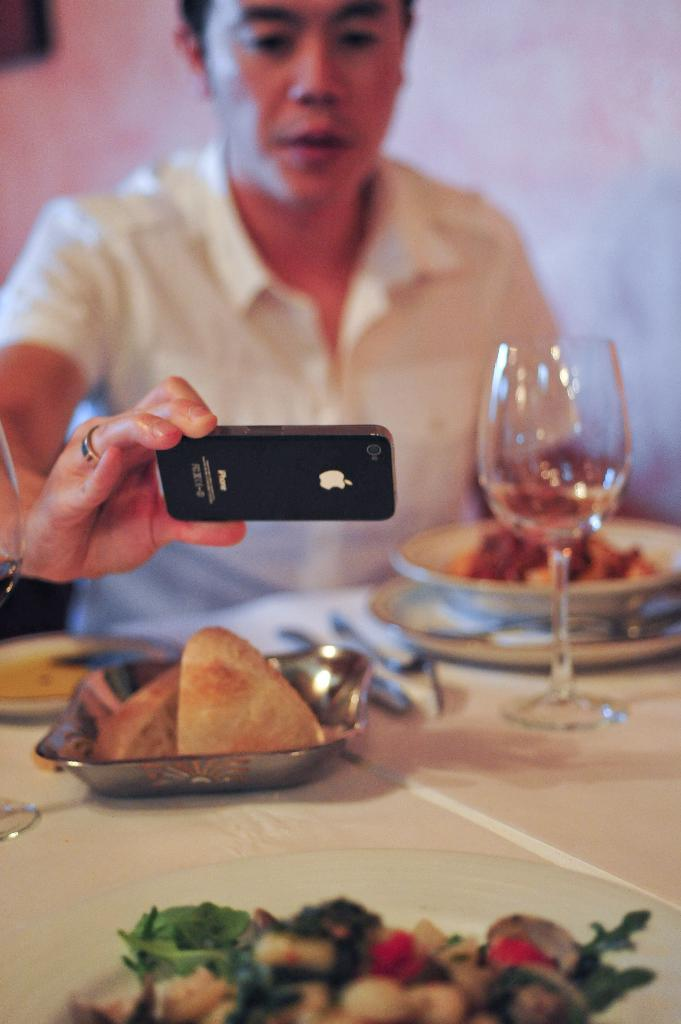What is the person in the image doing? The person is sitting in the image. What is on the table in the image? There is a glass, a plate, a bowl, and a tray on the table in the image. What is on the table that might be used for eating or drinking? There is food, a glass, and a plate on the table. What is the person holding in the image? The person is holding a mobile in the image. What can be seen in the background of the image? There is a wall in the background of the image. How many leaves are on the table in the image? There are no leaves present on the table in the image. What type of flock is visible in the image? There is no flock visible in the image. 